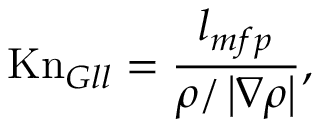Convert formula to latex. <formula><loc_0><loc_0><loc_500><loc_500>K n _ { G l l } = \frac { l _ { m f p } } { \rho / \left | \nabla \rho \right | } ,</formula> 